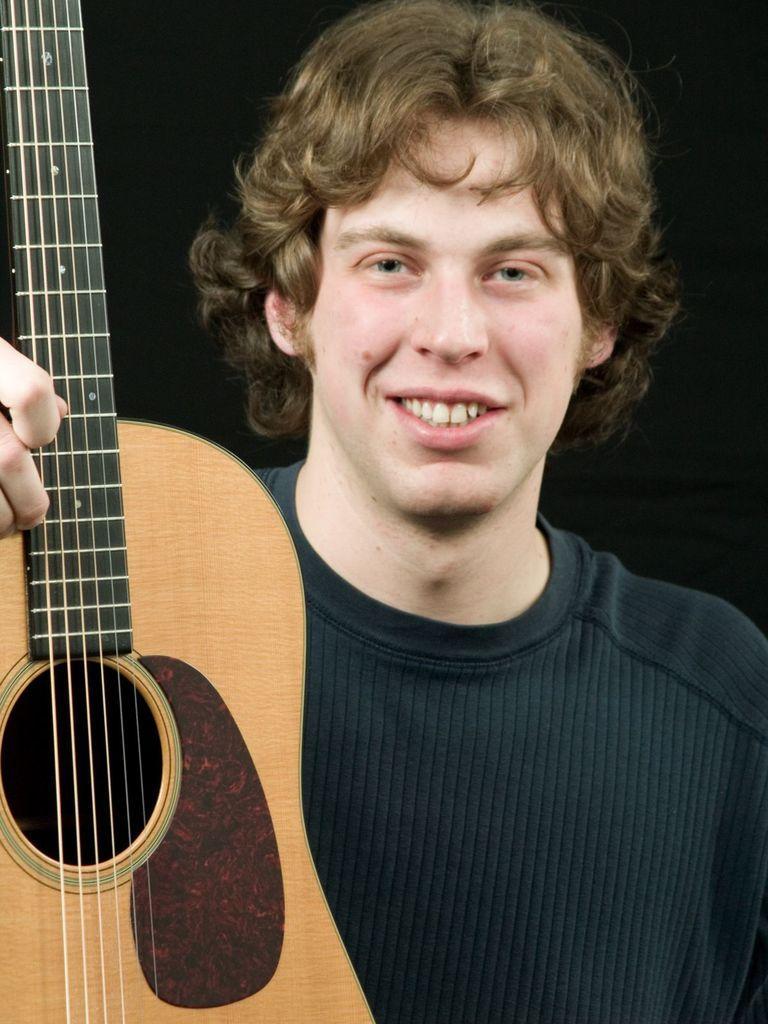Describe this image in one or two sentences. In the above picture there is person who is holding a guitar and moving the strings of the guitar. He wore a black t shirt and giving a smile. Picture background is black in color. 